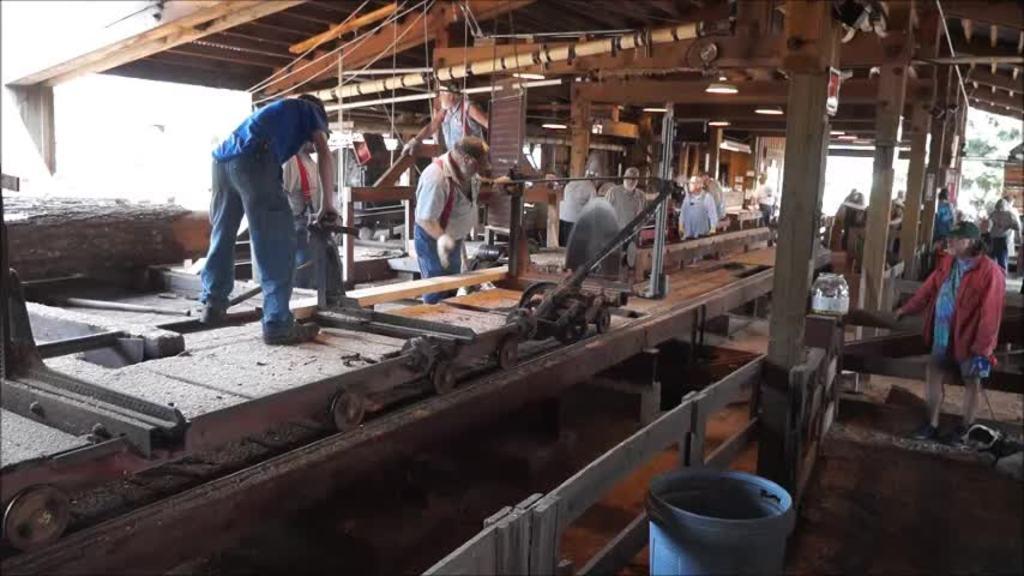Could you give a brief overview of what you see in this image? In this image I can see few people are working. I can see few wooden objects, wooden pillars, blue color object and few objects around. 